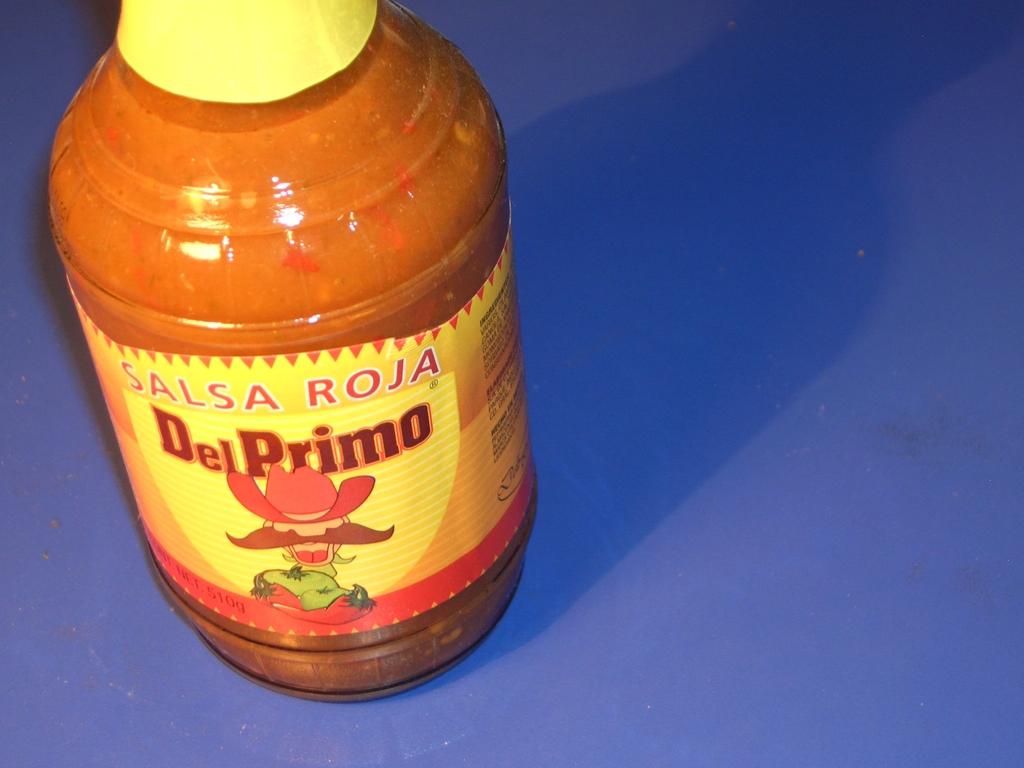What brand is this product?
Offer a terse response. Del primo. How many grams are in this bottle?
Keep it short and to the point. 510. 